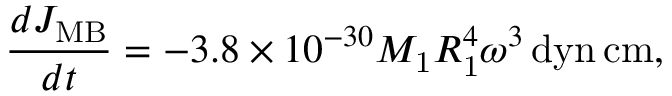<formula> <loc_0><loc_0><loc_500><loc_500>\frac { d J _ { M B } } { d t } = - 3 . 8 \times 1 0 ^ { - 3 0 } M _ { 1 } R _ { 1 } ^ { 4 } \omega ^ { 3 } \, d y n \, c m ,</formula> 